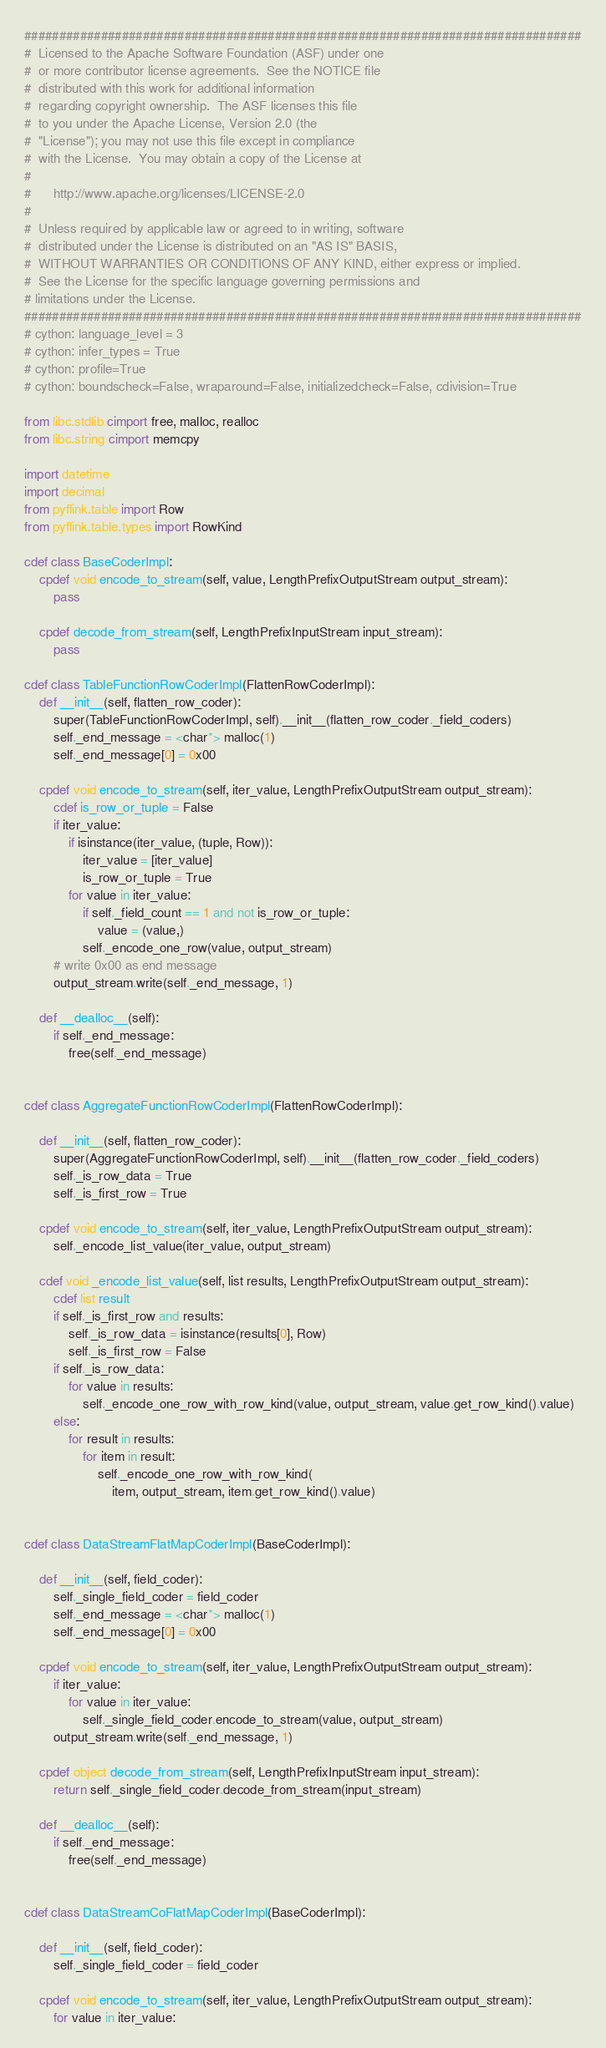<code> <loc_0><loc_0><loc_500><loc_500><_Cython_>################################################################################
#  Licensed to the Apache Software Foundation (ASF) under one
#  or more contributor license agreements.  See the NOTICE file
#  distributed with this work for additional information
#  regarding copyright ownership.  The ASF licenses this file
#  to you under the Apache License, Version 2.0 (the
#  "License"); you may not use this file except in compliance
#  with the License.  You may obtain a copy of the License at
#
#      http://www.apache.org/licenses/LICENSE-2.0
#
#  Unless required by applicable law or agreed to in writing, software
#  distributed under the License is distributed on an "AS IS" BASIS,
#  WITHOUT WARRANTIES OR CONDITIONS OF ANY KIND, either express or implied.
#  See the License for the specific language governing permissions and
# limitations under the License.
################################################################################
# cython: language_level = 3
# cython: infer_types = True
# cython: profile=True
# cython: boundscheck=False, wraparound=False, initializedcheck=False, cdivision=True

from libc.stdlib cimport free, malloc, realloc
from libc.string cimport memcpy

import datetime
import decimal
from pyflink.table import Row
from pyflink.table.types import RowKind

cdef class BaseCoderImpl:
    cpdef void encode_to_stream(self, value, LengthPrefixOutputStream output_stream):
        pass

    cpdef decode_from_stream(self, LengthPrefixInputStream input_stream):
        pass

cdef class TableFunctionRowCoderImpl(FlattenRowCoderImpl):
    def __init__(self, flatten_row_coder):
        super(TableFunctionRowCoderImpl, self).__init__(flatten_row_coder._field_coders)
        self._end_message = <char*> malloc(1)
        self._end_message[0] = 0x00

    cpdef void encode_to_stream(self, iter_value, LengthPrefixOutputStream output_stream):
        cdef is_row_or_tuple = False
        if iter_value:
            if isinstance(iter_value, (tuple, Row)):
                iter_value = [iter_value]
                is_row_or_tuple = True
            for value in iter_value:
                if self._field_count == 1 and not is_row_or_tuple:
                    value = (value,)
                self._encode_one_row(value, output_stream)
        # write 0x00 as end message
        output_stream.write(self._end_message, 1)

    def __dealloc__(self):
        if self._end_message:
            free(self._end_message)


cdef class AggregateFunctionRowCoderImpl(FlattenRowCoderImpl):

    def __init__(self, flatten_row_coder):
        super(AggregateFunctionRowCoderImpl, self).__init__(flatten_row_coder._field_coders)
        self._is_row_data = True
        self._is_first_row = True

    cpdef void encode_to_stream(self, iter_value, LengthPrefixOutputStream output_stream):
        self._encode_list_value(iter_value, output_stream)

    cdef void _encode_list_value(self, list results, LengthPrefixOutputStream output_stream):
        cdef list result
        if self._is_first_row and results:
            self._is_row_data = isinstance(results[0], Row)
            self._is_first_row = False
        if self._is_row_data:
            for value in results:
                self._encode_one_row_with_row_kind(value, output_stream, value.get_row_kind().value)
        else:
            for result in results:
                for item in result:
                    self._encode_one_row_with_row_kind(
                        item, output_stream, item.get_row_kind().value)


cdef class DataStreamFlatMapCoderImpl(BaseCoderImpl):

    def __init__(self, field_coder):
        self._single_field_coder = field_coder
        self._end_message = <char*> malloc(1)
        self._end_message[0] = 0x00

    cpdef void encode_to_stream(self, iter_value, LengthPrefixOutputStream output_stream):
        if iter_value:
            for value in iter_value:
                self._single_field_coder.encode_to_stream(value, output_stream)
        output_stream.write(self._end_message, 1)

    cpdef object decode_from_stream(self, LengthPrefixInputStream input_stream):
        return self._single_field_coder.decode_from_stream(input_stream)

    def __dealloc__(self):
        if self._end_message:
            free(self._end_message)


cdef class DataStreamCoFlatMapCoderImpl(BaseCoderImpl):

    def __init__(self, field_coder):
        self._single_field_coder = field_coder

    cpdef void encode_to_stream(self, iter_value, LengthPrefixOutputStream output_stream):
        for value in iter_value:</code> 